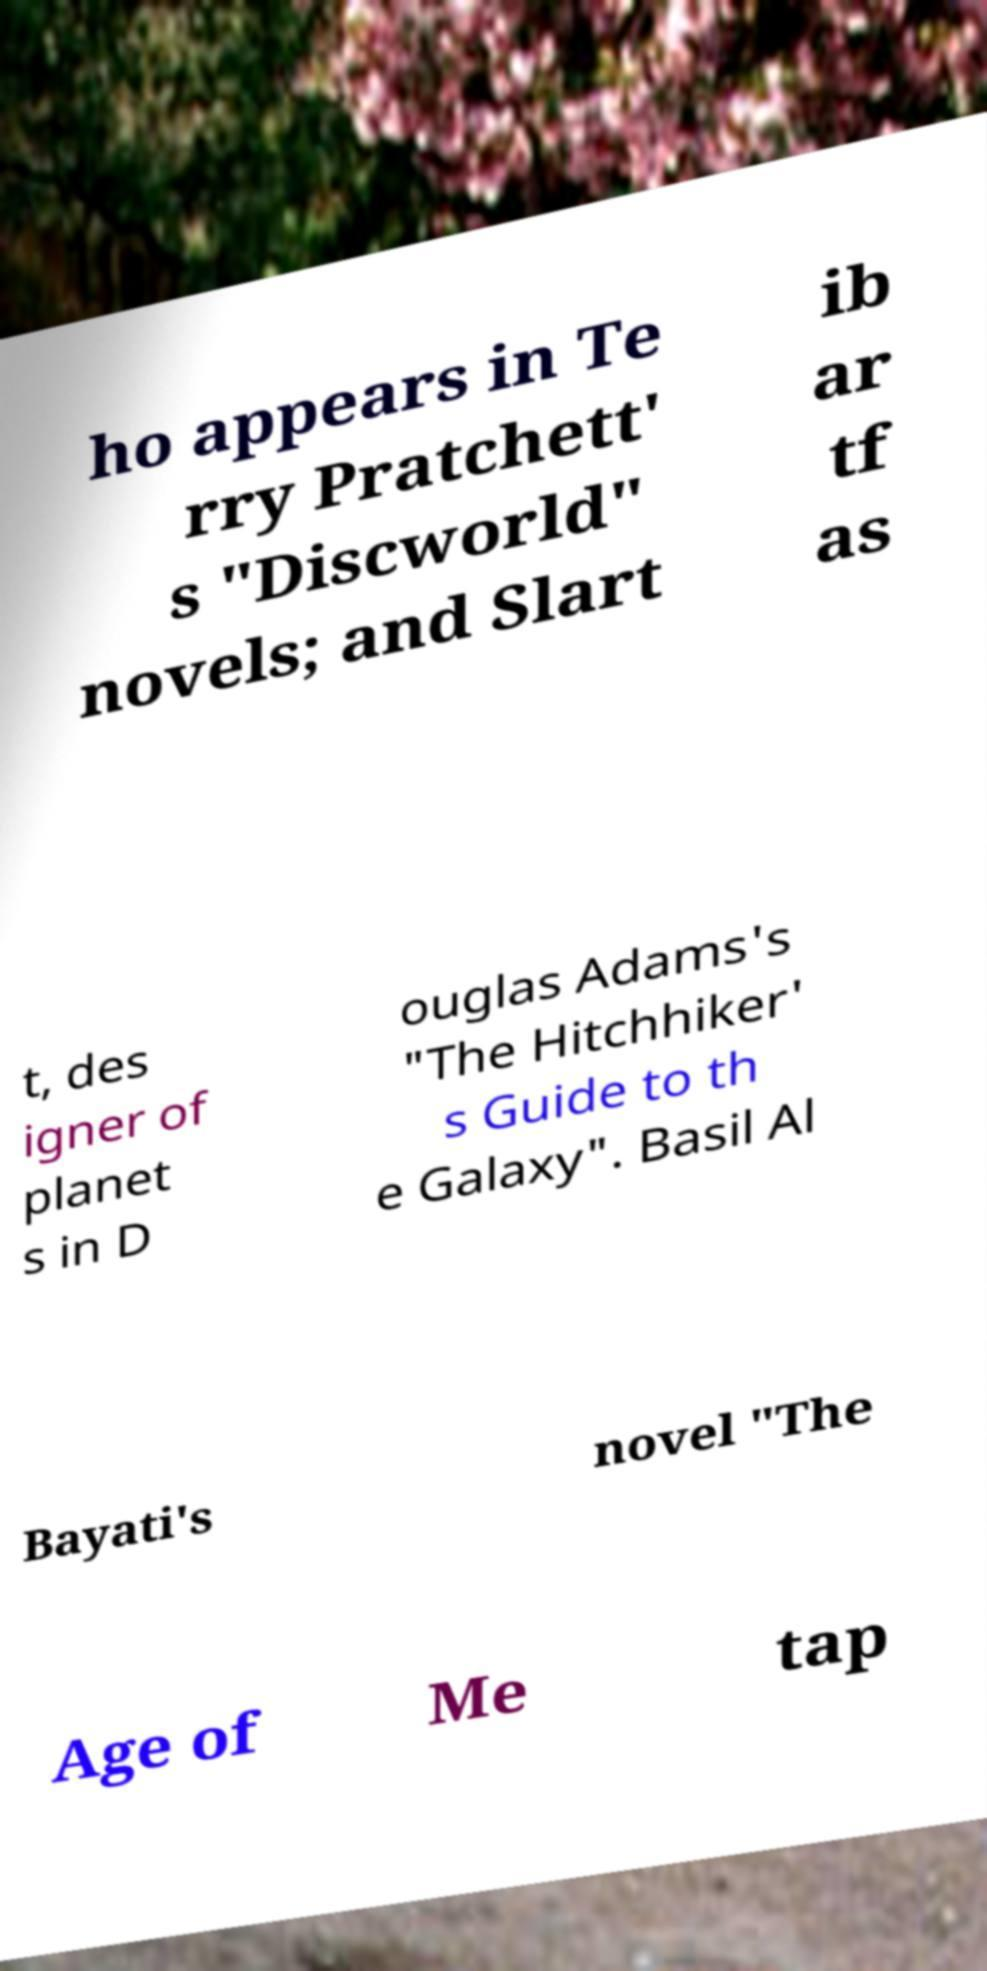For documentation purposes, I need the text within this image transcribed. Could you provide that? ho appears in Te rry Pratchett' s "Discworld" novels; and Slart ib ar tf as t, des igner of planet s in D ouglas Adams's "The Hitchhiker' s Guide to th e Galaxy". Basil Al Bayati's novel "The Age of Me tap 